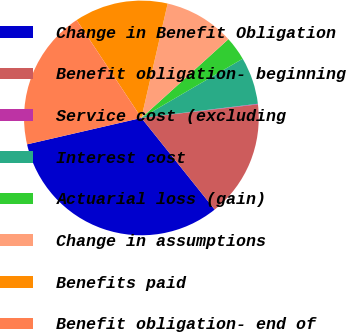Convert chart. <chart><loc_0><loc_0><loc_500><loc_500><pie_chart><fcel>Change in Benefit Obligation<fcel>Benefit obligation- beginning<fcel>Service cost (excluding<fcel>Interest cost<fcel>Actuarial loss (gain)<fcel>Change in assumptions<fcel>Benefits paid<fcel>Benefit obligation- end of<nl><fcel>32.13%<fcel>16.11%<fcel>0.08%<fcel>6.49%<fcel>3.29%<fcel>9.7%<fcel>12.9%<fcel>19.31%<nl></chart> 